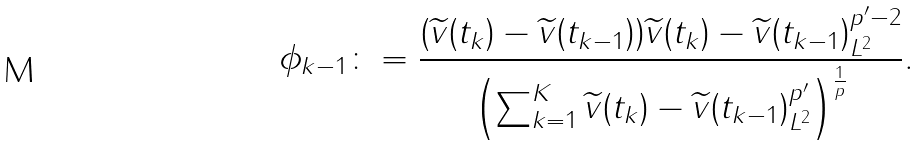Convert formula to latex. <formula><loc_0><loc_0><loc_500><loc_500>\phi _ { k - 1 } \colon = \frac { ( \widetilde { v } ( t _ { k } ) - \widetilde { v } ( t _ { k - 1 } ) ) \| \widetilde { v } ( t _ { k } ) - \widetilde { v } ( t _ { k - 1 } ) \| _ { L ^ { 2 } } ^ { p ^ { \prime } - 2 } } { \left ( \sum _ { k = 1 } ^ { K } \| \widetilde { v } ( t _ { k } ) - \widetilde { v } ( t _ { k - 1 } ) \| ^ { p ^ { \prime } } _ { L ^ { 2 } } \right ) ^ { \frac { 1 } { p } } } .</formula> 